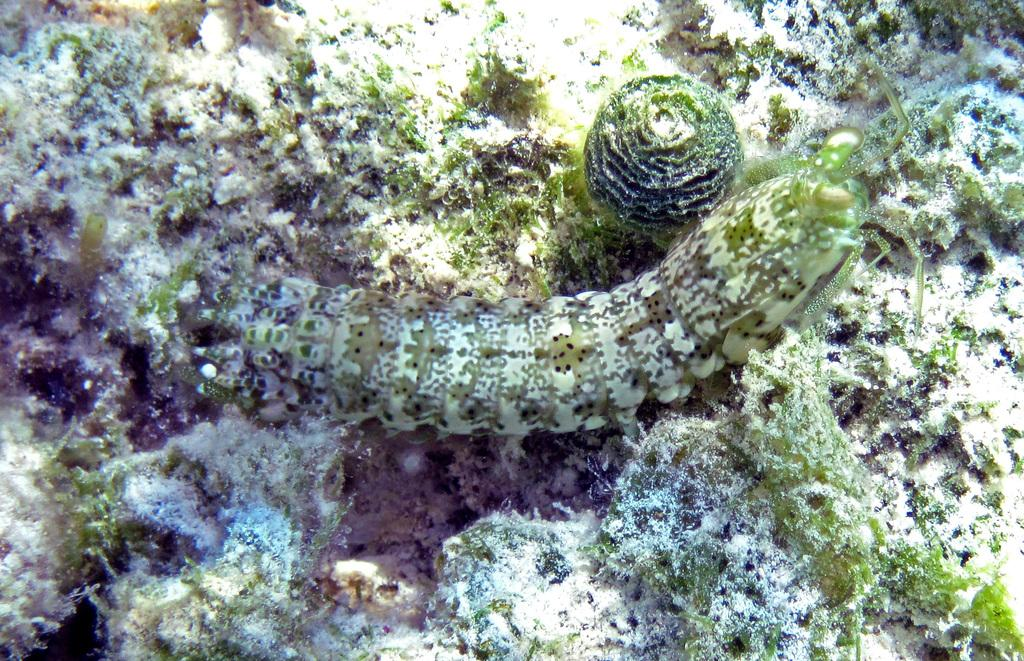What type of creature can be seen in the image? There is an insect in the image. What type of vegetation is present in the image? There are underwater plants in the image. What else can be seen in the image besides the insect and underwater plants? Algae are present in the image. What type of horse can be seen swimming in the image? There is no horse present in the image; it features an insect and underwater plants. 